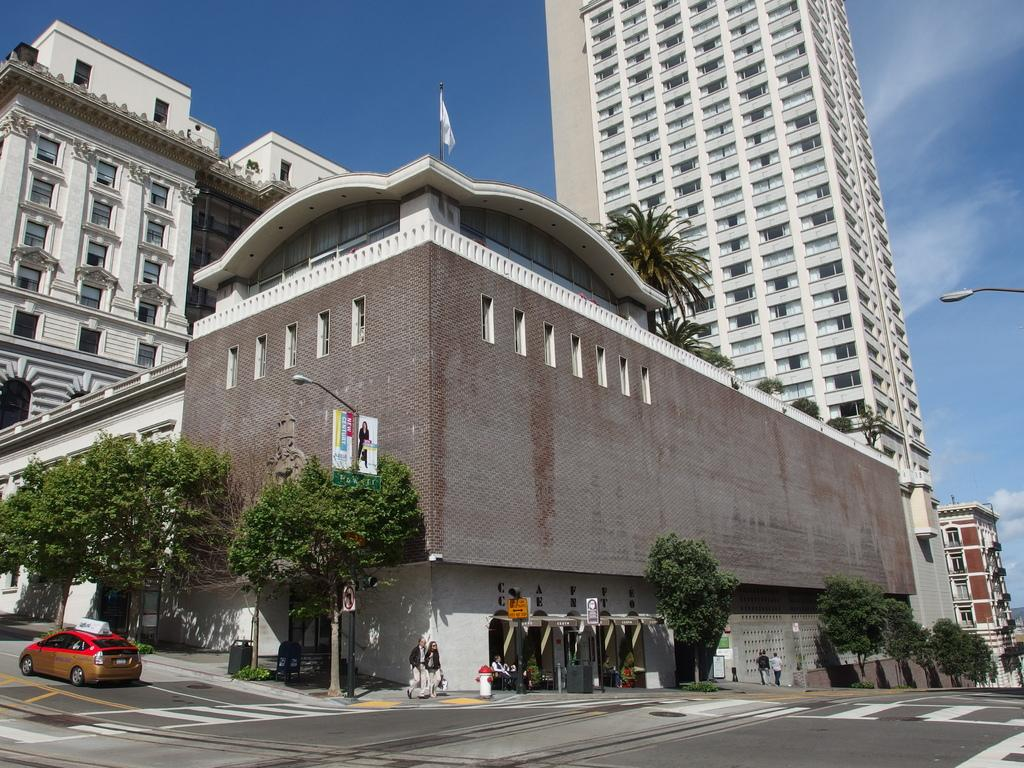What is on the road in the image? There is a car on the road in the image. What are the two people in the image doing? The two people are walking. What type of vegetation can be seen in the image? Trees are visible in the image. What type of structures are present in the image? Buildings are present in the image. Where is the light coming from in the image? The light is coming from the right side of the image. What can be seen in the background of the image? The sky is visible in the background of the image. How many girls are walking with their mother in the image? There are no girls or mothers present in the image; it features a car on the road, two people walking, trees, buildings, light, and the sky. 